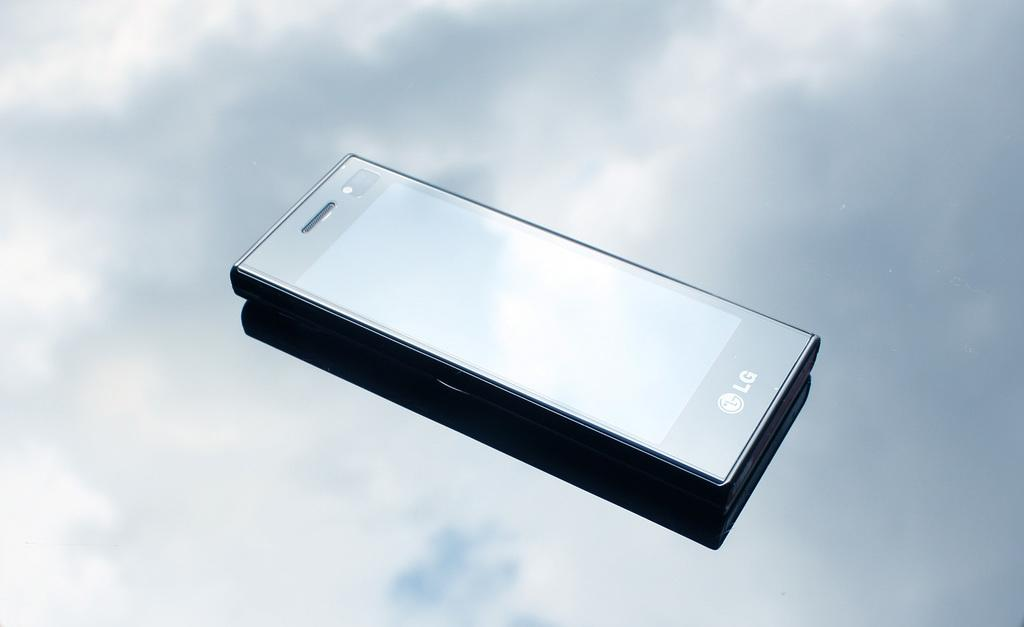<image>
Offer a succinct explanation of the picture presented. An LG electronic device against a background of clouds and blue. 